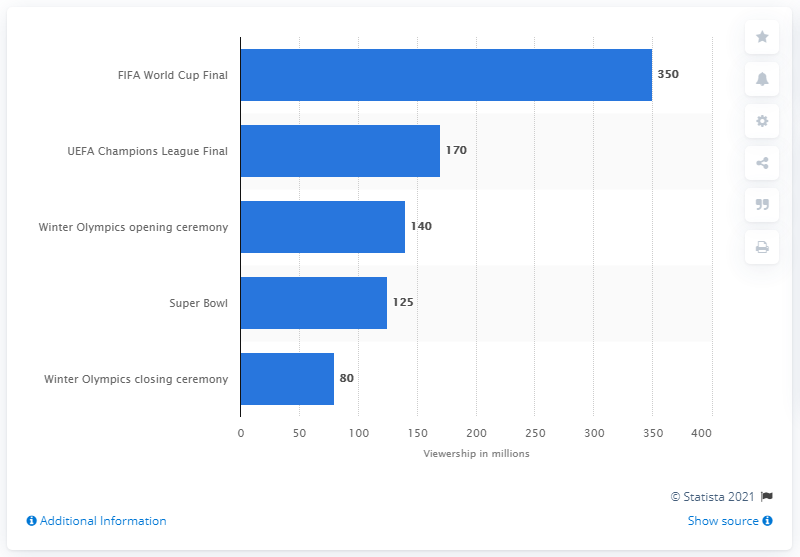Draw attention to some important aspects in this diagram. In 2014, it is projected that 350 people will watch the FIFA World Cup Final. 